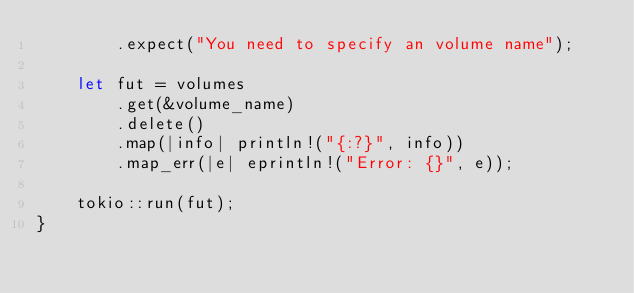Convert code to text. <code><loc_0><loc_0><loc_500><loc_500><_Rust_>        .expect("You need to specify an volume name");

    let fut = volumes
        .get(&volume_name)
        .delete()
        .map(|info| println!("{:?}", info))
        .map_err(|e| eprintln!("Error: {}", e));

    tokio::run(fut);
}
</code> 